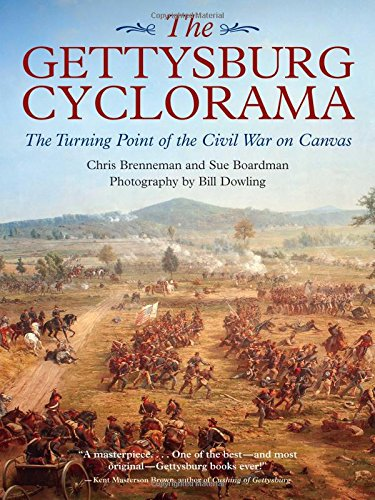Can you describe the scene depicted on the cover of the book? The cover features a vivid depiction of the Battle of Gettysburg. It shows a dynamic and chaotic battle scene with Union and Confederate soldiers engaged in combat, highlighted by the dramatic use of color and light which emphasizes the intensity and drama of the conflict. 